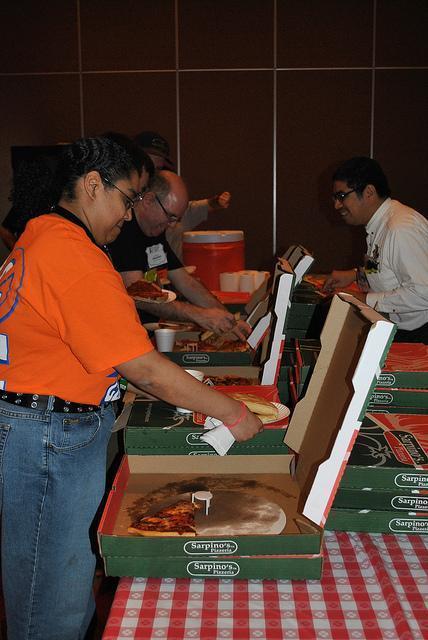How many people are there?
Give a very brief answer. 4. How many giraffes are in the image?
Give a very brief answer. 0. 